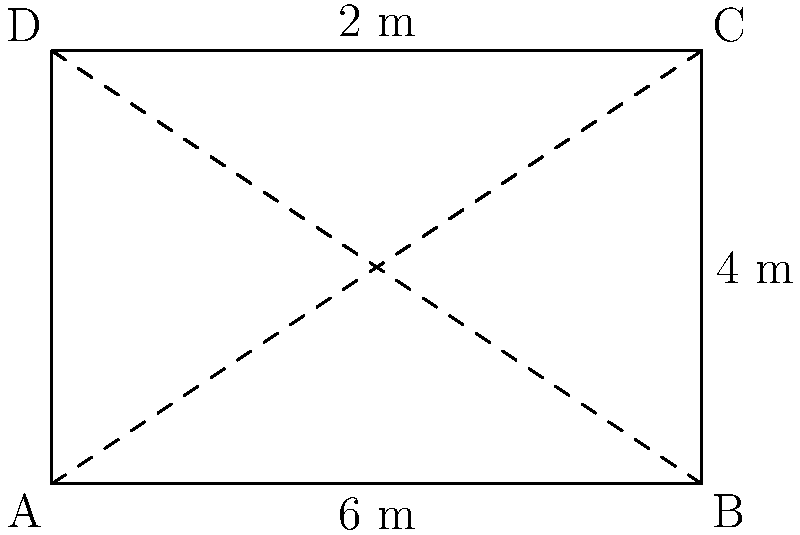As part of a community development project, you're planning a garden plot with a unique shape. The plot is rectangular with three straight sides and one curved side. The straight sides measure 6 m, 4 m, and 6 m, while the curved side bulges outward with a maximum distance of 2 m from the straight line it replaces. What is the approximate perimeter of this garden plot? To calculate the approximate perimeter of the garden plot, we need to:

1. Sum the lengths of the three straight sides:
   $6 + 4 + 6 = 16$ m

2. Estimate the length of the curved side:
   - The straight line it replaces would be 4 m
   - We can approximate the curve as an arc of a circle
   - The arc length is typically longer than the straight line by about 1.5 times the maximum bulge
   - Estimated additional length = $1.5 \times 2 = 3$ m
   - Estimated length of curved side = $4 + 3 = 7$ m

3. Sum all sides:
   Total perimeter $\approx 16 + 7 = 23$ m

Therefore, the approximate perimeter of the garden plot is 23 meters.
Answer: $23$ m 